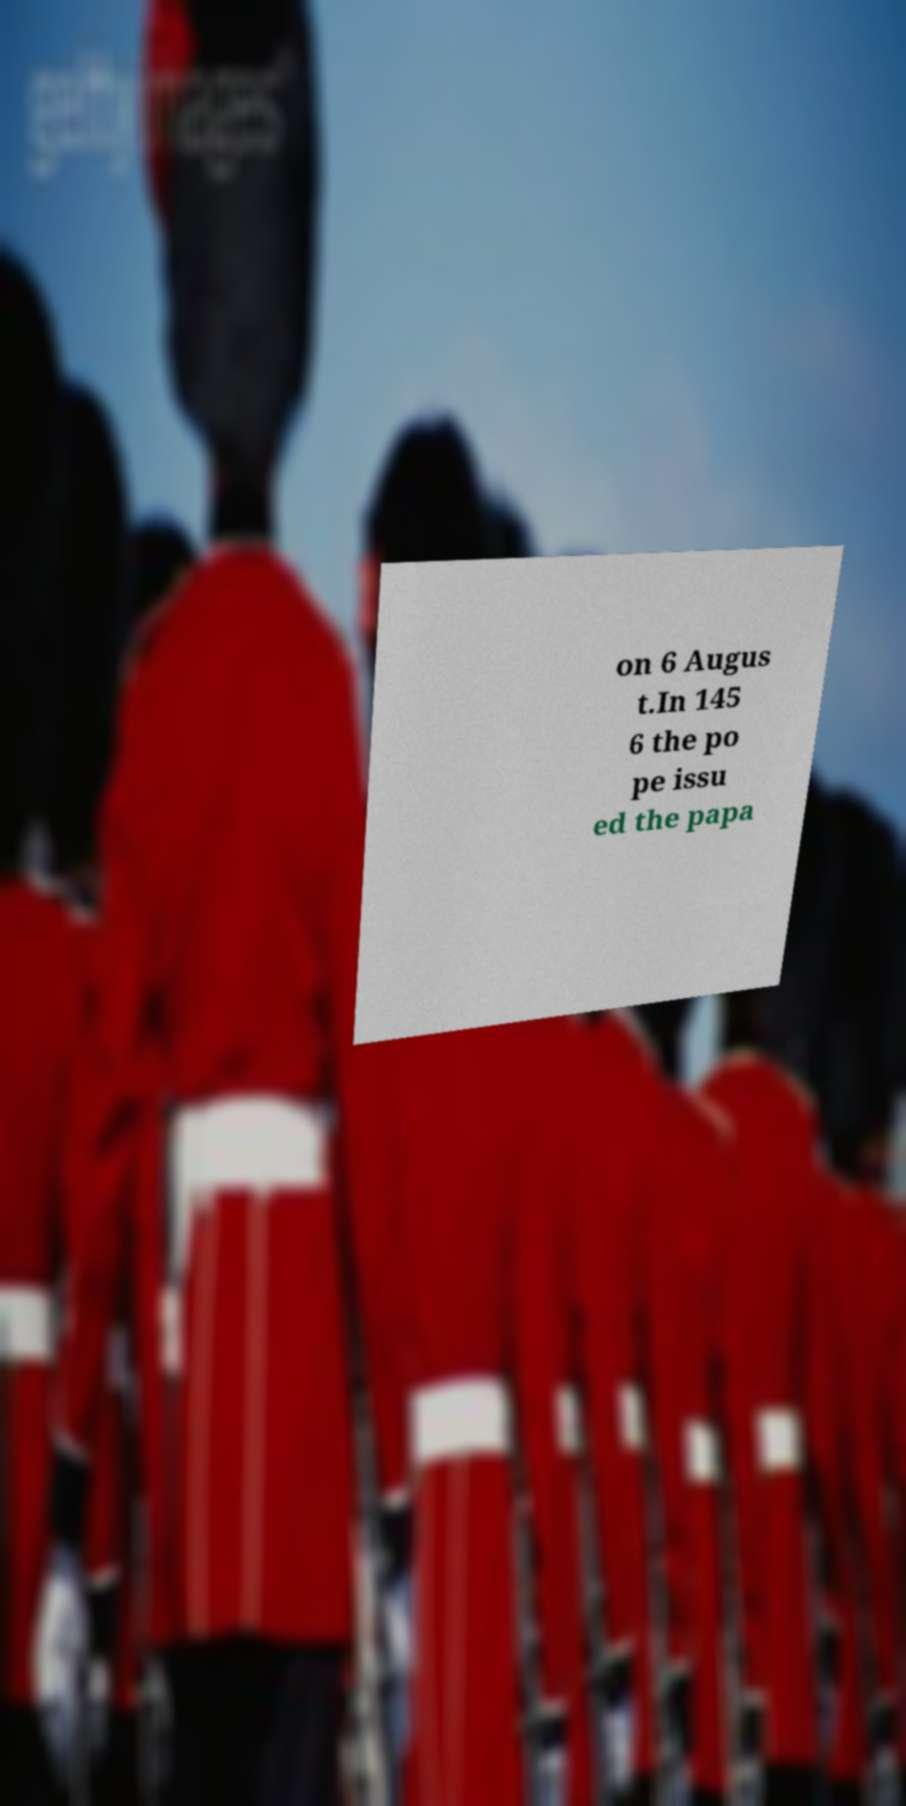Please identify and transcribe the text found in this image. on 6 Augus t.In 145 6 the po pe issu ed the papa 